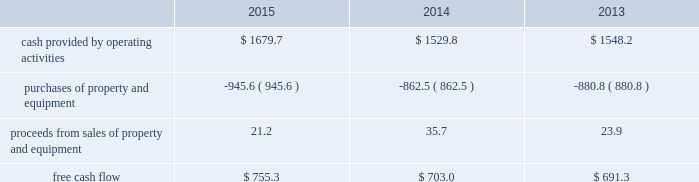Financial assurance we must provide financial assurance to governmental agencies and a variety of other entities under applicable environmental regulations relating to our landfill operations for capping , closure and post-closure costs , and related to our performance under certain collection , landfill and transfer station contracts .
We satisfy these financial assurance requirements by providing surety bonds , letters of credit , or insurance policies ( financial assurance instruments ) , or trust deposits , which are included in restricted cash and marketable securities and other assets in our consolidated balance sheets .
The amount of the financial assurance requirements for capping , closure and post-closure costs is determined by applicable state environmental regulations .
The financial assurance requirements for capping , closure and post-closure costs may be associated with a portion of the landfill or the entire landfill .
Generally , states require a third-party engineering specialist to determine the estimated capping , closure and post-closure costs that are used to determine the required amount of financial assurance for a landfill .
The amount of financial assurance required can , and generally will , differ from the obligation determined and recorded under u.s .
Gaap .
The amount of the financial assurance requirements related to contract performance varies by contract .
Additionally , we must provide financial assurance for our insurance program and collateral for certain performance obligations .
We do not expect a material increase in financial assurance requirements during 2016 , although the mix of financial assurance instruments may change .
These financial assurance instruments are issued in the normal course of business and are not considered indebtedness .
Because we currently have no liability for the financial assurance instruments , they are not reflected in our consolidated balance sheets ; however , we record capping , closure and post-closure liabilities and insurance liabilities as they are incurred .
Off-balance sheet arrangements we have no off-balance sheet debt or similar obligations , other than operating leases and financial assurances , which are not classified as debt .
We have no transactions or obligations with related parties that are not disclosed , consolidated into or reflected in our reported financial position or results of operations .
We have not guaranteed any third-party debt .
Free cash flow we define free cash flow , which is not a measure determined in accordance with u.s .
Gaap , as cash provided by operating activities less purchases of property and equipment , plus proceeds from sales of property and equipment , as presented in our consolidated statements of cash flows .
The table calculates our free cash flow for the years ended december 31 , 2015 , 2014 and 2013 ( in millions of dollars ) : .
For a discussion of the changes in the components of free cash flow , see our discussion regarding cash flows provided by operating activities and cash flows used in investing activities contained elsewhere in this management 2019s discussion and analysis of financial condition and results of operations. .
What was the percentage change in the free cash flow from 2014 to 2015? 
Rationale: the free cash flow increased by 7.4% from 2014 to 2015
Computations: ((755.3 - 703.0) / 703.0)
Answer: 0.0744. 